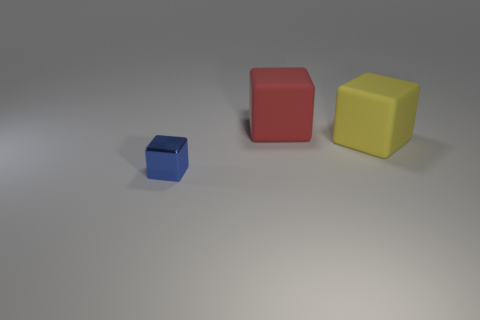Subtract all matte blocks. How many blocks are left? 1 Add 2 small cyan rubber objects. How many objects exist? 5 Add 3 large green metal cylinders. How many large green metal cylinders exist? 3 Subtract 1 blue cubes. How many objects are left? 2 Subtract 3 blocks. How many blocks are left? 0 Subtract all purple cubes. Subtract all gray spheres. How many cubes are left? 3 Subtract all cyan balls. How many red cubes are left? 1 Subtract all small yellow rubber cylinders. Subtract all big rubber objects. How many objects are left? 1 Add 1 small blue things. How many small blue things are left? 2 